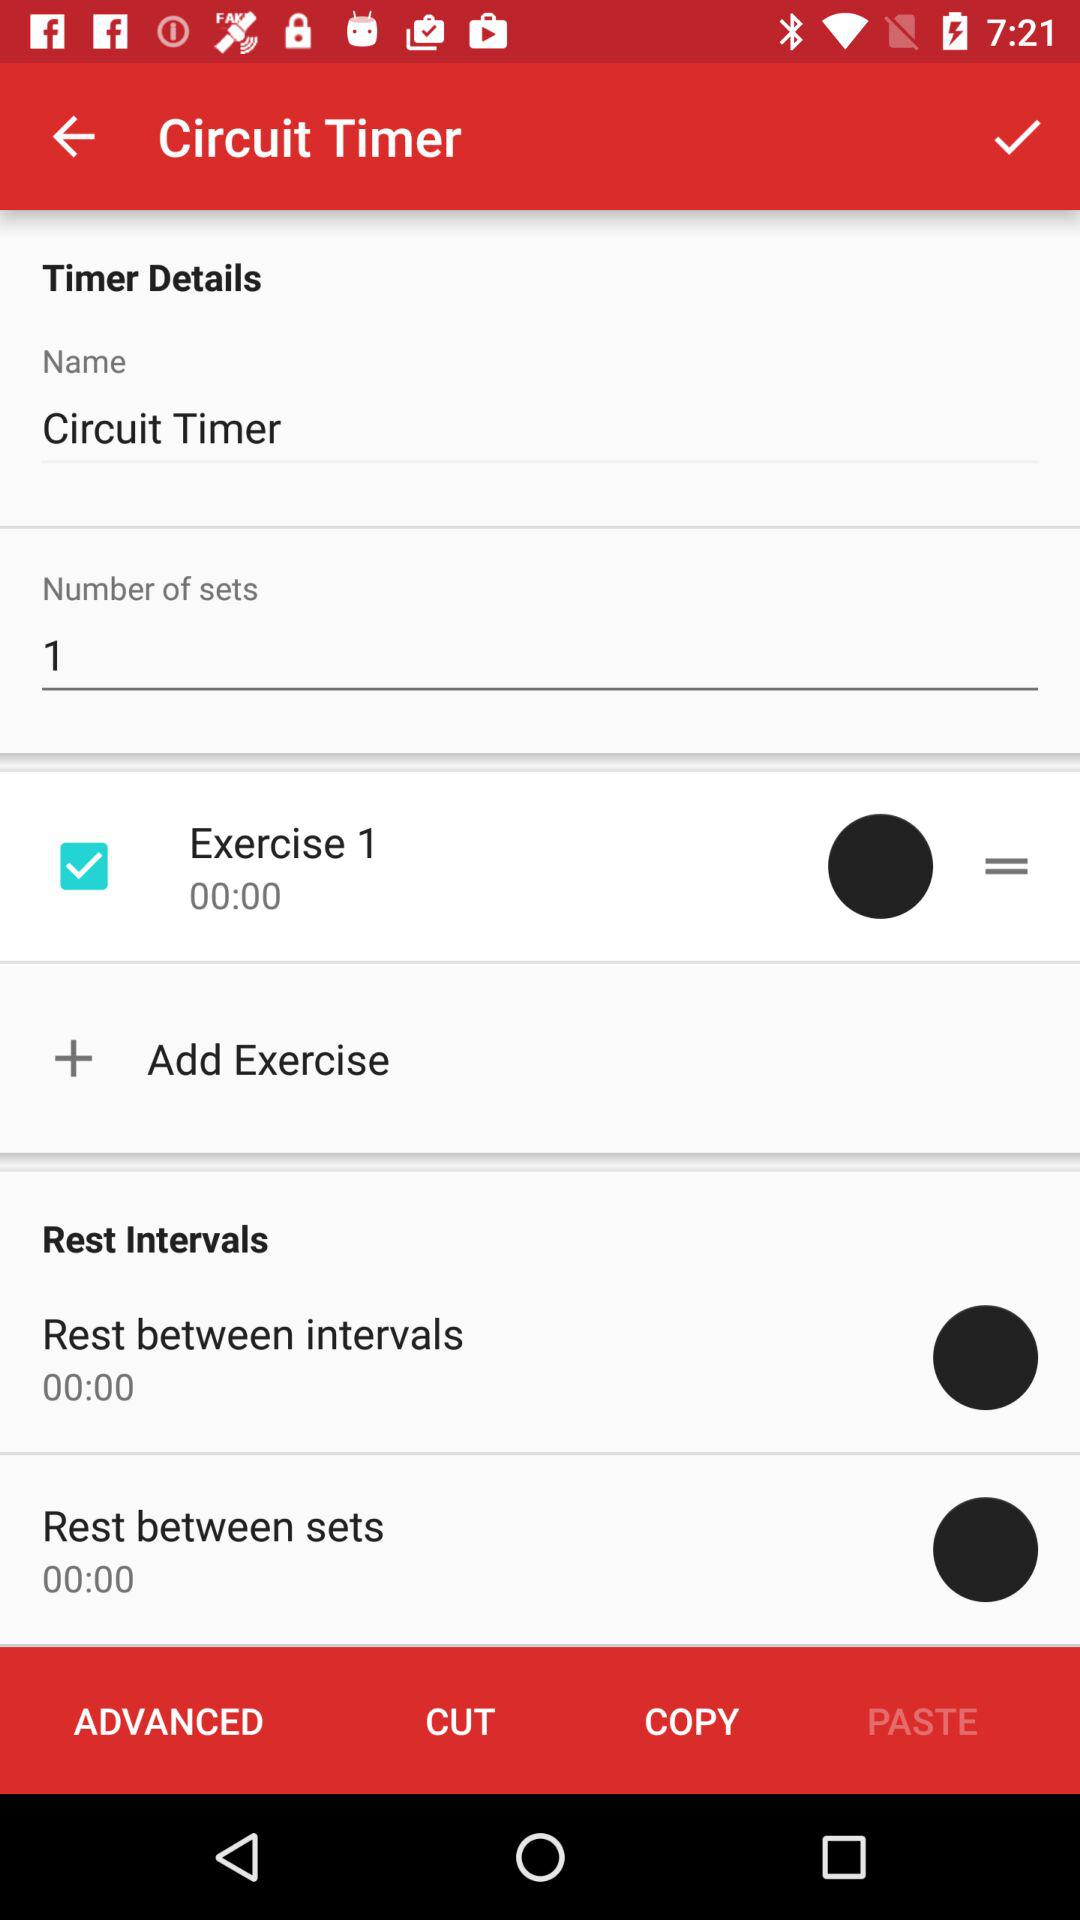What is the name? The name is Circuit Timer. 